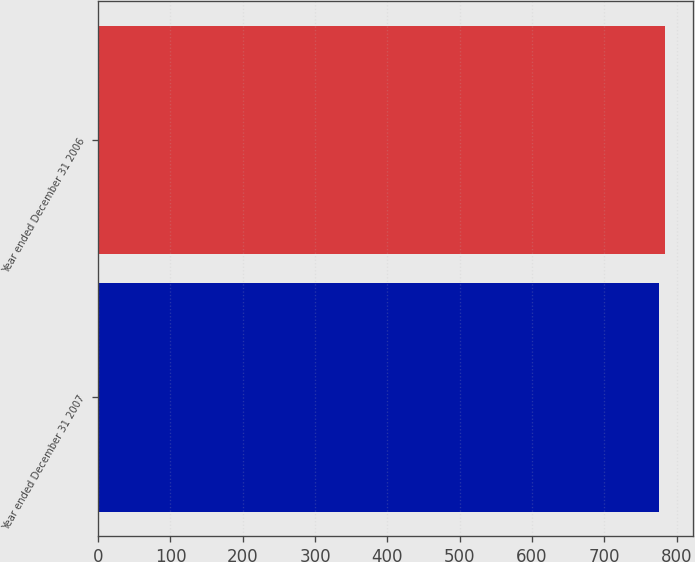Convert chart. <chart><loc_0><loc_0><loc_500><loc_500><bar_chart><fcel>Year ended December 31 2007<fcel>Year ended December 31 2006<nl><fcel>776<fcel>784<nl></chart> 